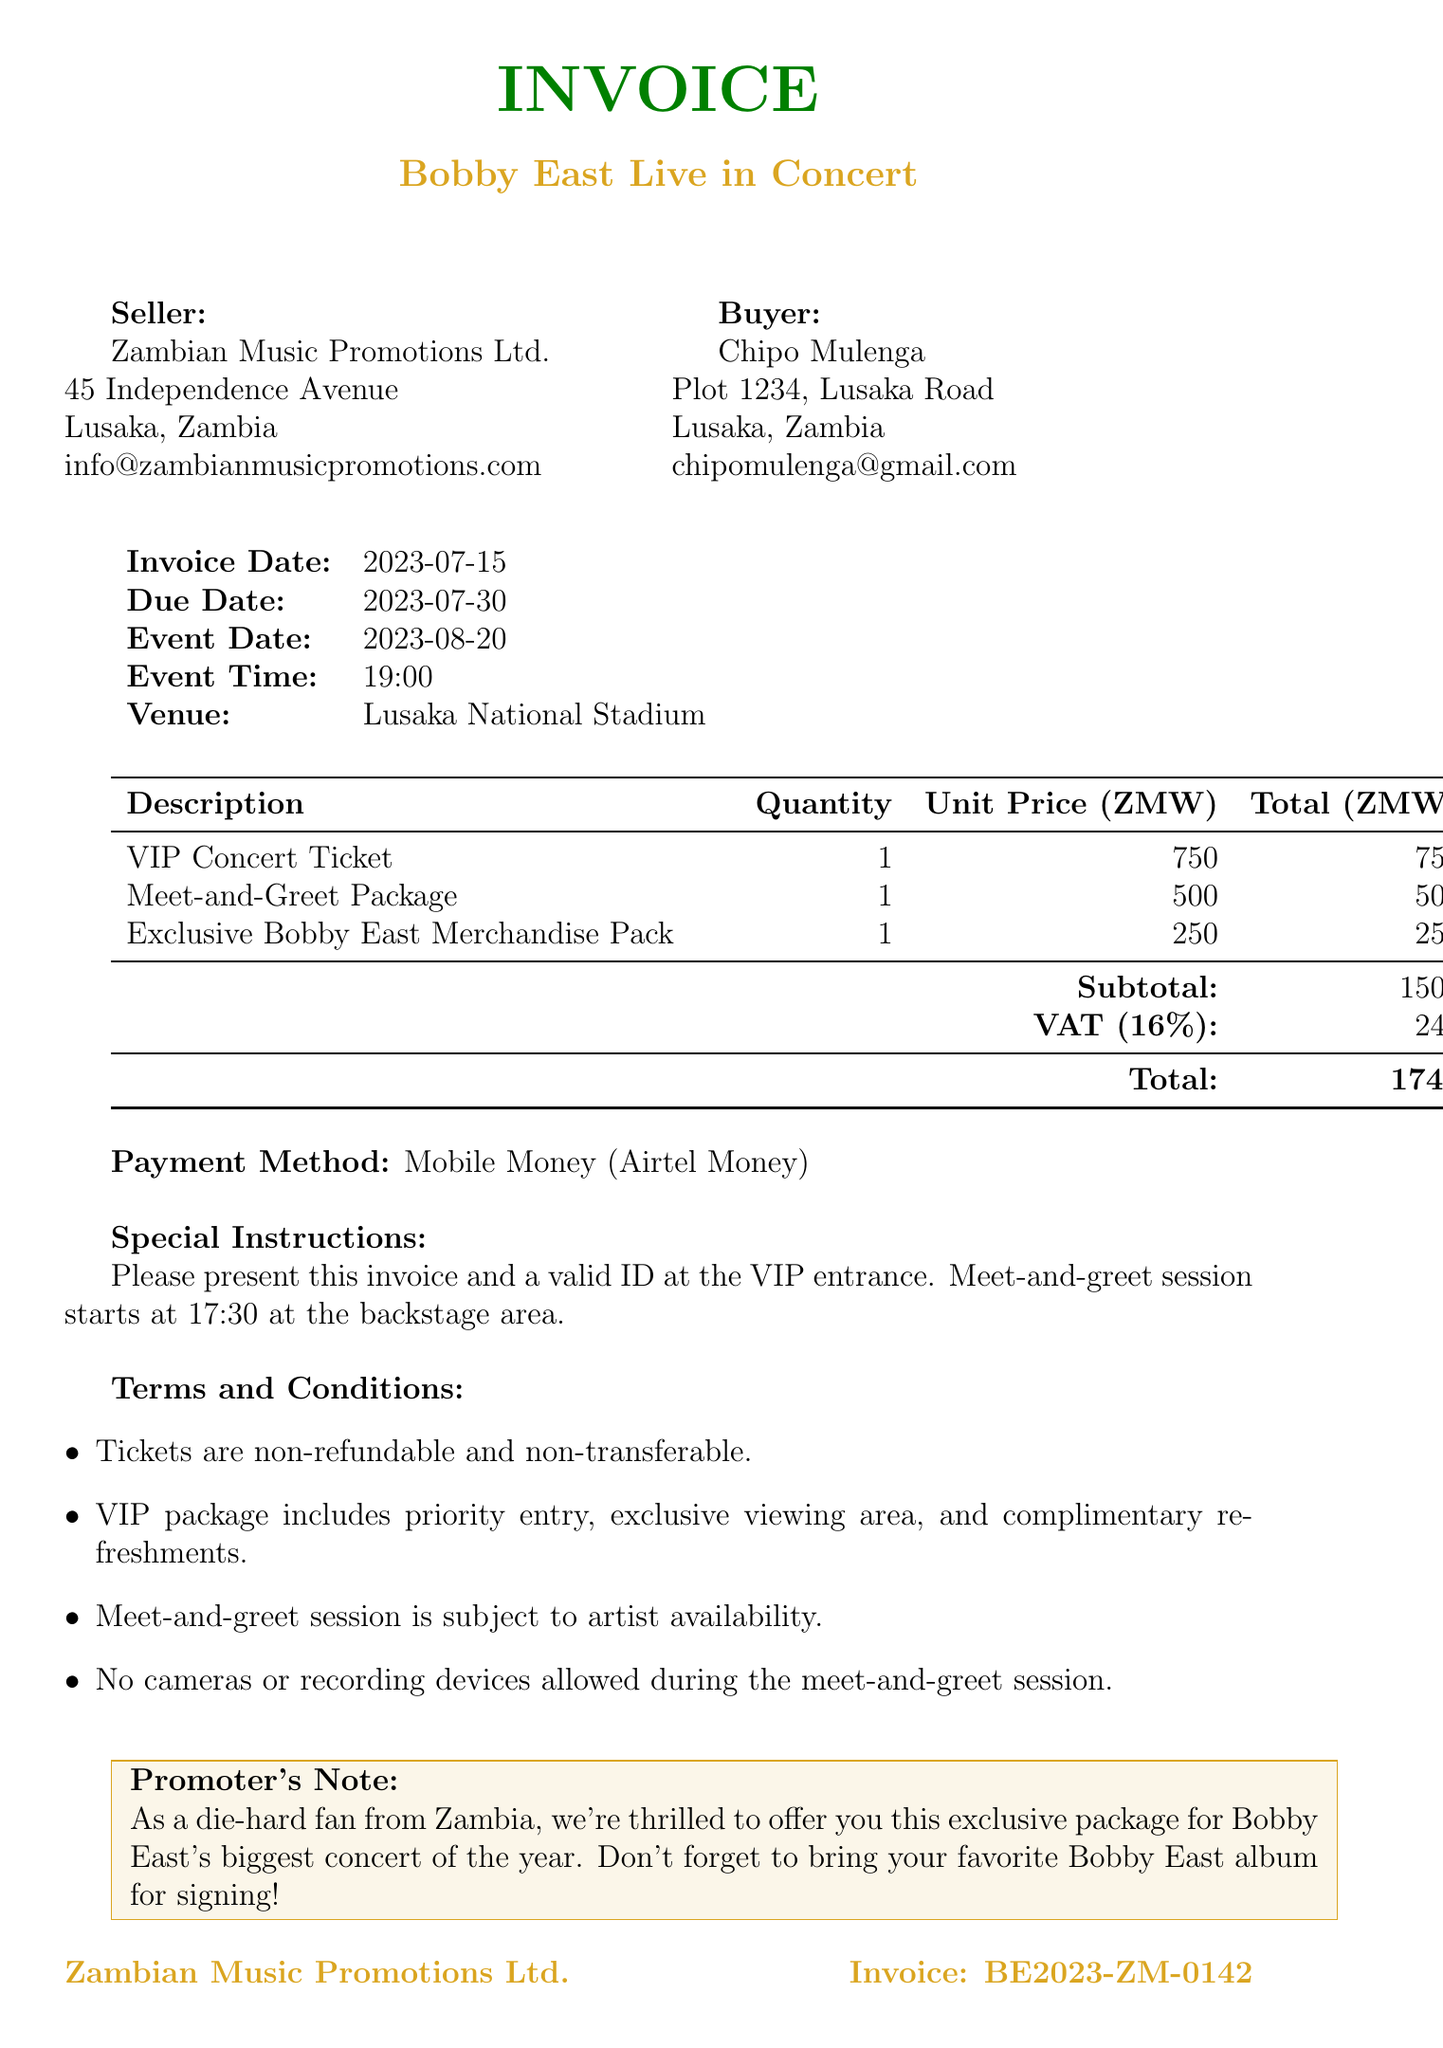What is the invoice number? The invoice number identifies the document and is stated at the top of the invoice.
Answer: BE2023-ZM-0142 Who is the buyer? The buyer's name is mentioned in the buyer's section of the document.
Answer: Chipo Mulenga What is the total amount due? The total amount is computed and shown at the bottom of the invoice.
Answer: 1740 When is the event date? The event date is specified in the event details section of the document.
Answer: 2023-08-20 What is the quantity of VIP concert tickets purchased? The quantity of VIP concert tickets is provided in the items section of the invoice.
Answer: 1 What is the seller's email address? The seller's email address can be found in the seller's information section.
Answer: info@zambianmusicpromotions.com What is the VAT rate applied in this invoice? The VAT rate is explicitly stated in the tax section of the document.
Answer: 16% What special instruction is given for the VIP entrance? Special instructions are listed at the bottom of the document regarding what to present at the VIP entrance.
Answer: Please present this invoice and a valid ID at the VIP entrance What does the VIP package include? The terms of the VIP package are summarized in the terms and conditions section.
Answer: Priority entry, exclusive viewing area, and complimentary refreshments 